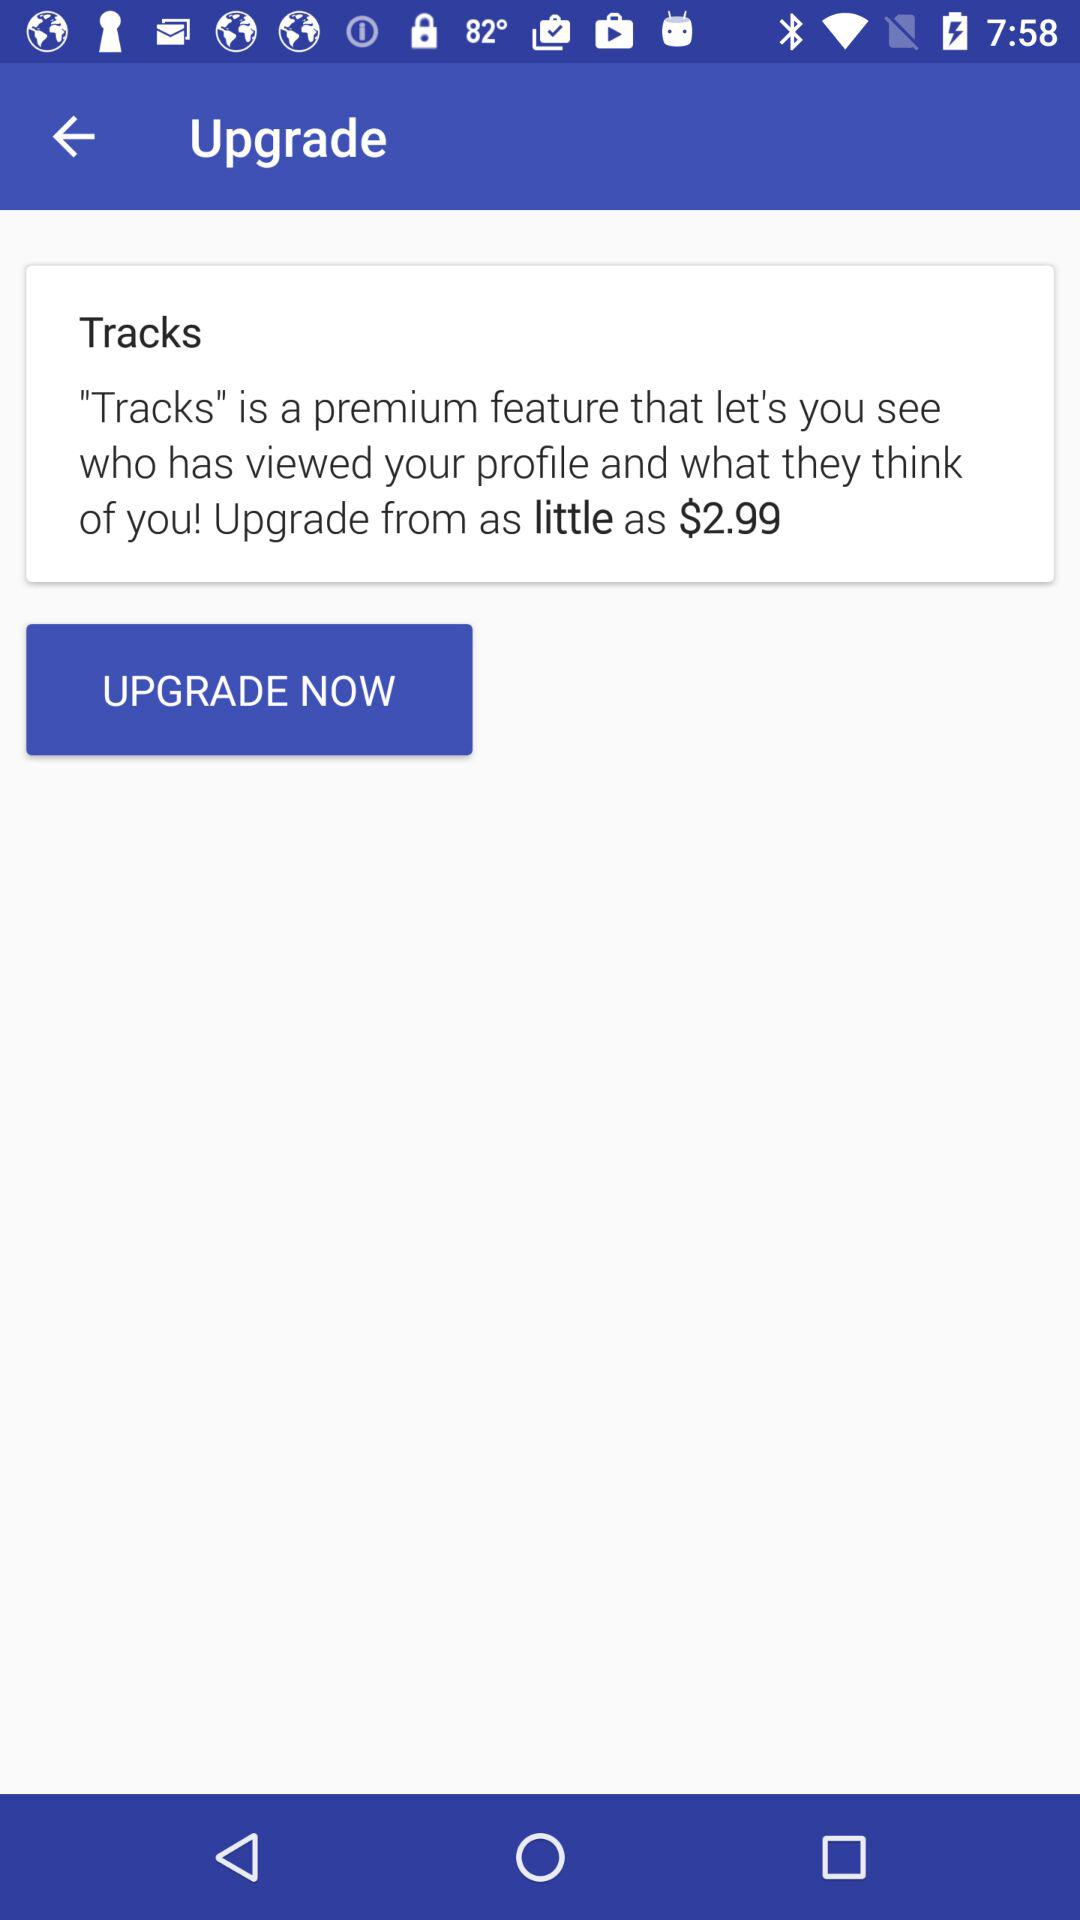What does the "Tracks" feature do? The "Tracks" feature "let's you see who has viewed your profile and what they think of you!". 